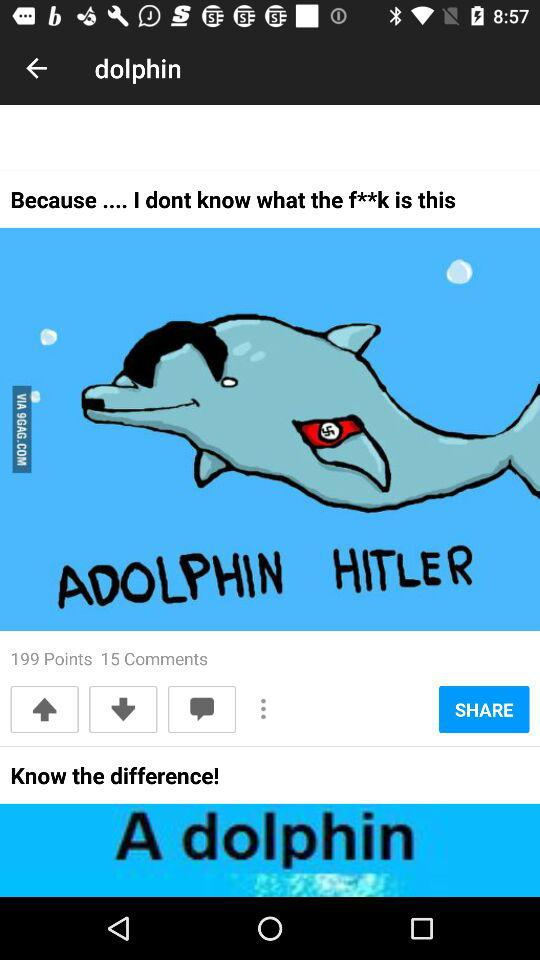How many points are there? There are 199 points. 